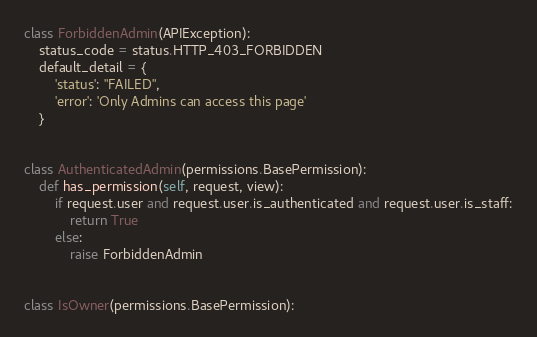Convert code to text. <code><loc_0><loc_0><loc_500><loc_500><_Python_>
class ForbiddenAdmin(APIException):
    status_code = status.HTTP_403_FORBIDDEN
    default_detail = {
        'status': "FAILED",
        'error': 'Only Admins can access this page'
    }


class AuthenticatedAdmin(permissions.BasePermission):
    def has_permission(self, request, view):
        if request.user and request.user.is_authenticated and request.user.is_staff:
            return True
        else:
            raise ForbiddenAdmin


class IsOwner(permissions.BasePermission):</code> 